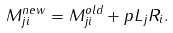Convert formula to latex. <formula><loc_0><loc_0><loc_500><loc_500>M ^ { n e w } _ { j i } = M ^ { o l d } _ { j i } + p L _ { j } R _ { i } .</formula> 